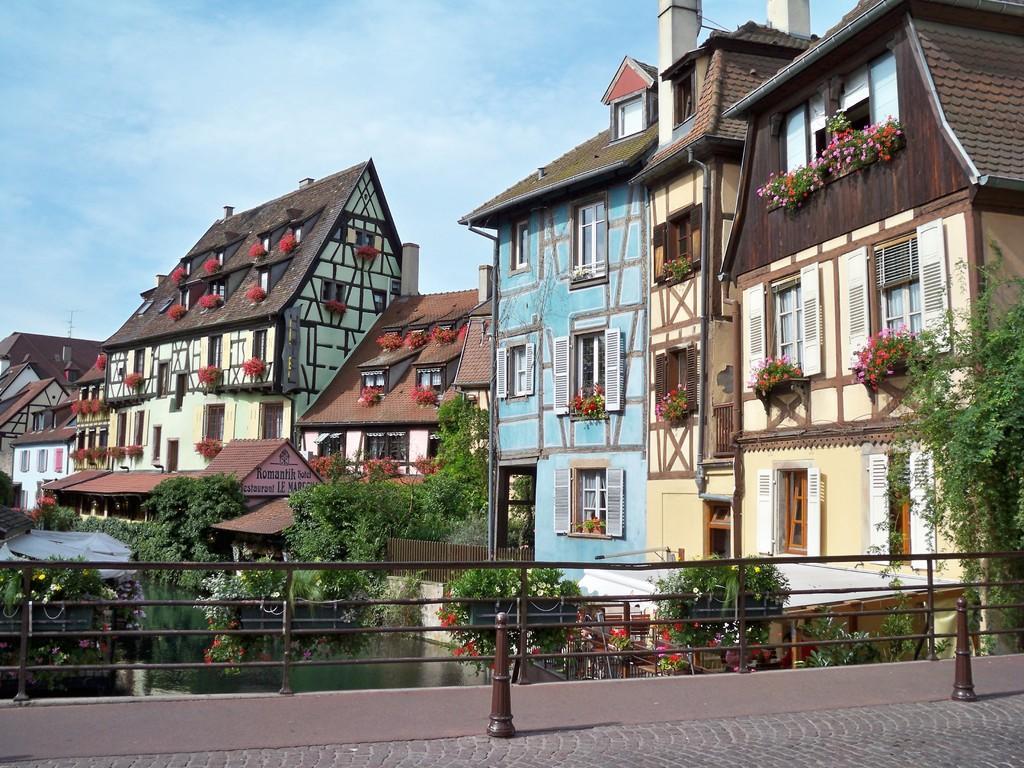Could you give a brief overview of what you see in this image? At the bottom of the picture, we see the pavement and the railing. In the middle of the picture, we see water and this water might be in the canal. In this picture, we see trees, flower pots, plants and buildings. At the top, we see the sky, which is blue in color. 